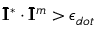<formula> <loc_0><loc_0><loc_500><loc_500>\bar { I } ^ { * } \cdot \bar { I } ^ { m } > \epsilon _ { d o t }</formula> 